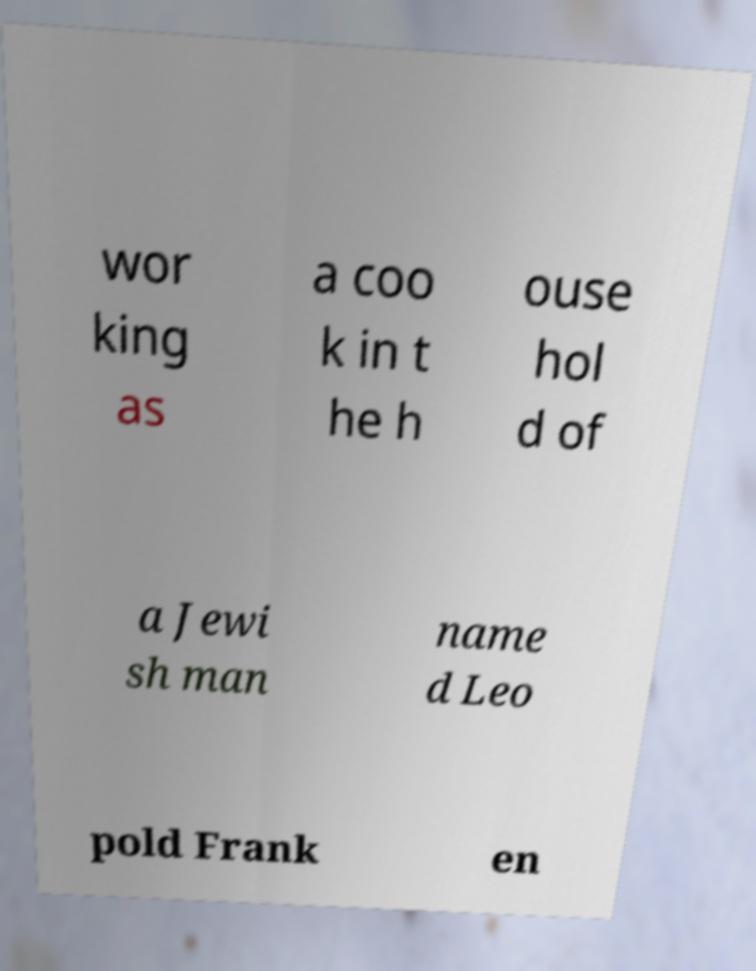Please read and relay the text visible in this image. What does it say? wor king as a coo k in t he h ouse hol d of a Jewi sh man name d Leo pold Frank en 